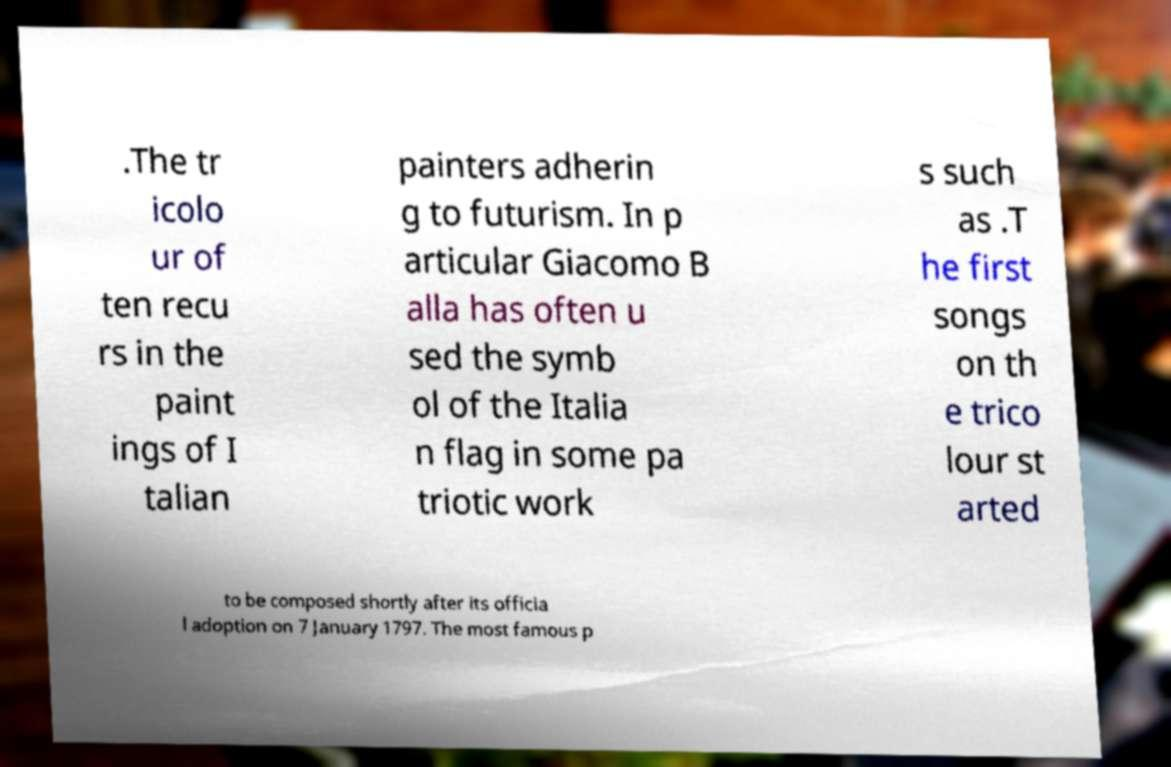I need the written content from this picture converted into text. Can you do that? .The tr icolo ur of ten recu rs in the paint ings of I talian painters adherin g to futurism. In p articular Giacomo B alla has often u sed the symb ol of the Italia n flag in some pa triotic work s such as .T he first songs on th e trico lour st arted to be composed shortly after its officia l adoption on 7 January 1797. The most famous p 